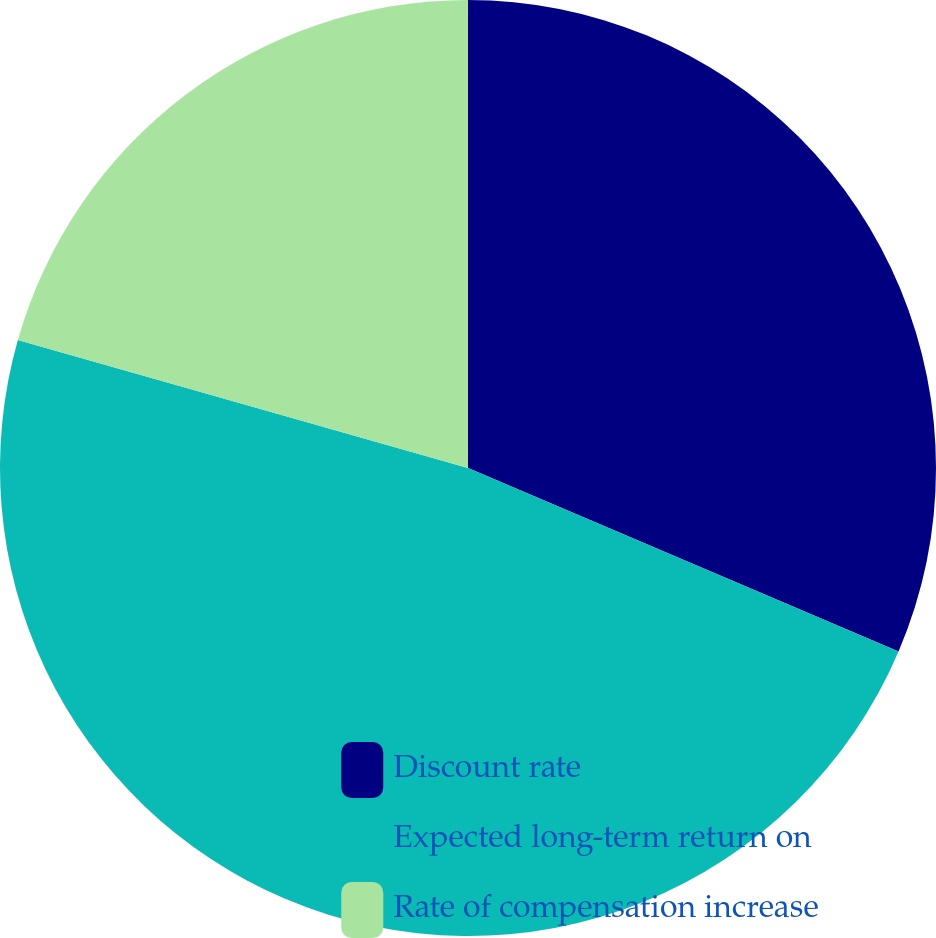Convert chart. <chart><loc_0><loc_0><loc_500><loc_500><pie_chart><fcel>Discount rate<fcel>Expected long-term return on<fcel>Rate of compensation increase<nl><fcel>31.41%<fcel>48.0%<fcel>20.59%<nl></chart> 